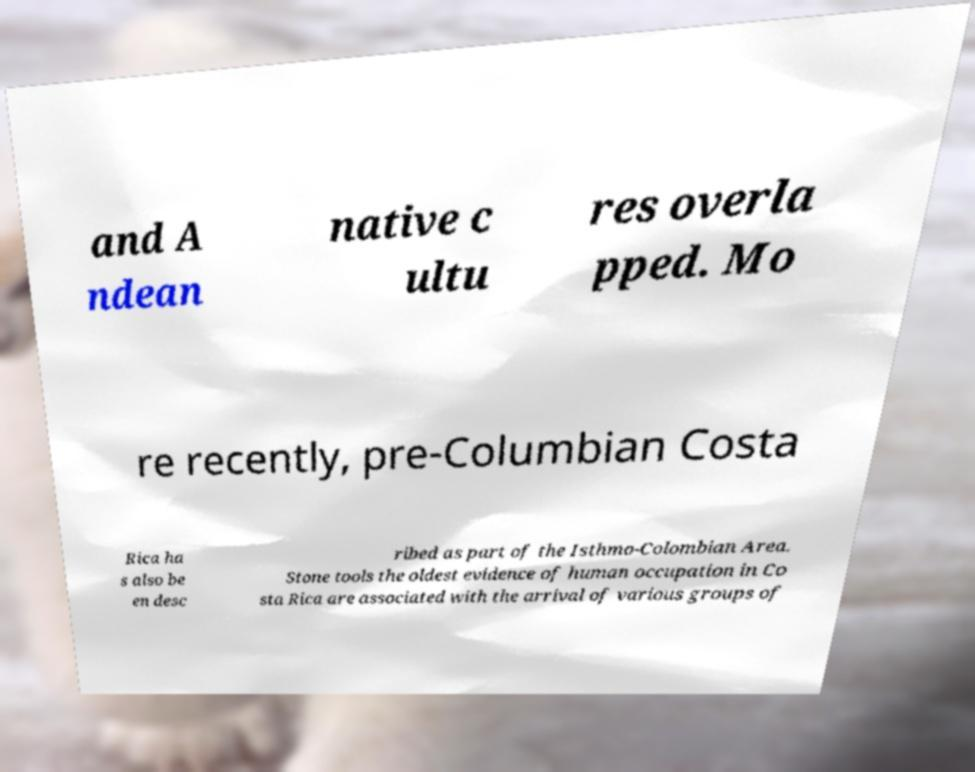Can you read and provide the text displayed in the image?This photo seems to have some interesting text. Can you extract and type it out for me? and A ndean native c ultu res overla pped. Mo re recently, pre-Columbian Costa Rica ha s also be en desc ribed as part of the Isthmo-Colombian Area. Stone tools the oldest evidence of human occupation in Co sta Rica are associated with the arrival of various groups of 